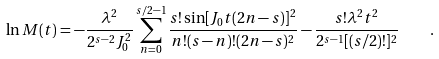Convert formula to latex. <formula><loc_0><loc_0><loc_500><loc_500>\ln M ( t ) = - \frac { \lambda ^ { 2 } } { 2 ^ { s - 2 } J _ { 0 } ^ { 2 } } \sum _ { n = 0 } ^ { s / 2 - 1 } \frac { s ! \sin [ J _ { 0 } t ( 2 n - s ) ] ^ { 2 } } { n ! ( s - n ) ! ( 2 n - s ) ^ { 2 } } - \frac { s ! \lambda ^ { 2 } t ^ { 2 } } { 2 ^ { s - 1 } [ ( s / 2 ) ! ] ^ { 2 } } \quad .</formula> 